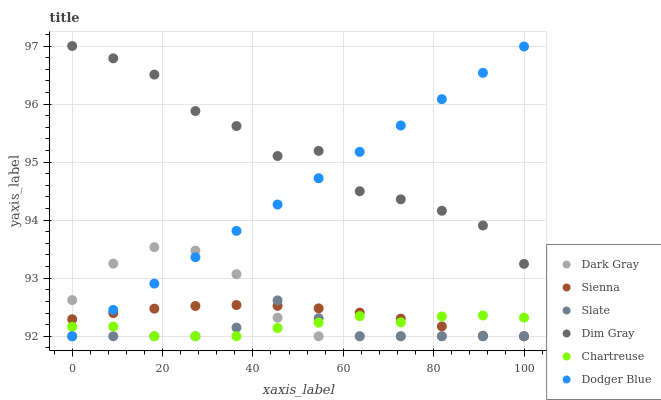Does Slate have the minimum area under the curve?
Answer yes or no. Yes. Does Dim Gray have the maximum area under the curve?
Answer yes or no. Yes. Does Dim Gray have the minimum area under the curve?
Answer yes or no. No. Does Slate have the maximum area under the curve?
Answer yes or no. No. Is Dodger Blue the smoothest?
Answer yes or no. Yes. Is Dim Gray the roughest?
Answer yes or no. Yes. Is Slate the smoothest?
Answer yes or no. No. Is Slate the roughest?
Answer yes or no. No. Does Sienna have the lowest value?
Answer yes or no. Yes. Does Dim Gray have the lowest value?
Answer yes or no. No. Does Dim Gray have the highest value?
Answer yes or no. Yes. Does Slate have the highest value?
Answer yes or no. No. Is Chartreuse less than Dim Gray?
Answer yes or no. Yes. Is Dim Gray greater than Chartreuse?
Answer yes or no. Yes. Does Dodger Blue intersect Slate?
Answer yes or no. Yes. Is Dodger Blue less than Slate?
Answer yes or no. No. Is Dodger Blue greater than Slate?
Answer yes or no. No. Does Chartreuse intersect Dim Gray?
Answer yes or no. No. 